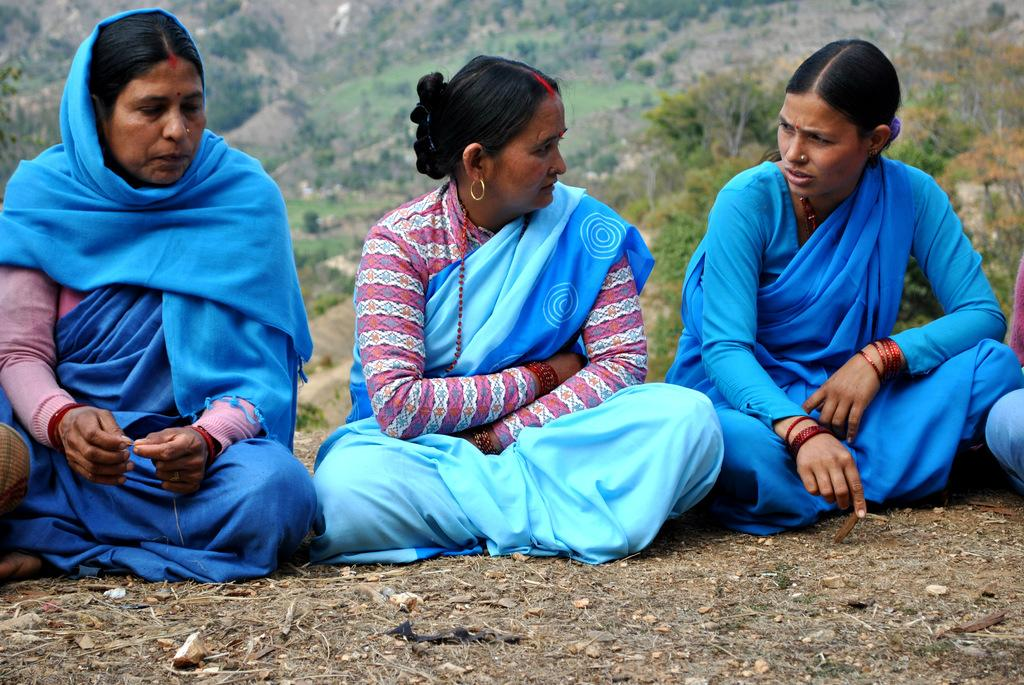How many women are in the image? There are three women in the image. What are the women doing in the image? The women are sitting on the ground. What can be seen in the background of the image? Hills and trees are visible in the background of the image. What type of songs are the women singing during their lunch break? There is no indication in the image that the women are singing or that they are on a lunch break, so it cannot be determined from the picture. 